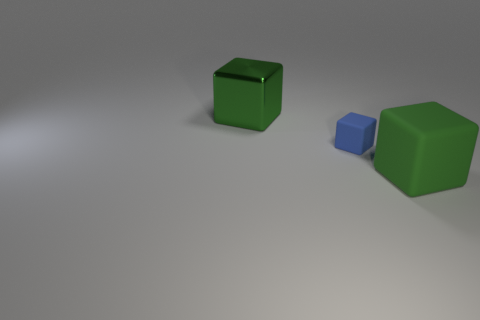What might be the size comparison between the green and blue objects? In the image, the blue block is substantially smaller than both of the green objects, which appear to be geometric cubes. The smaller blue block seems to be about a quarter to a third of the size of the larger green cubes, indicating a notable size discrepancy among the items depicted. 